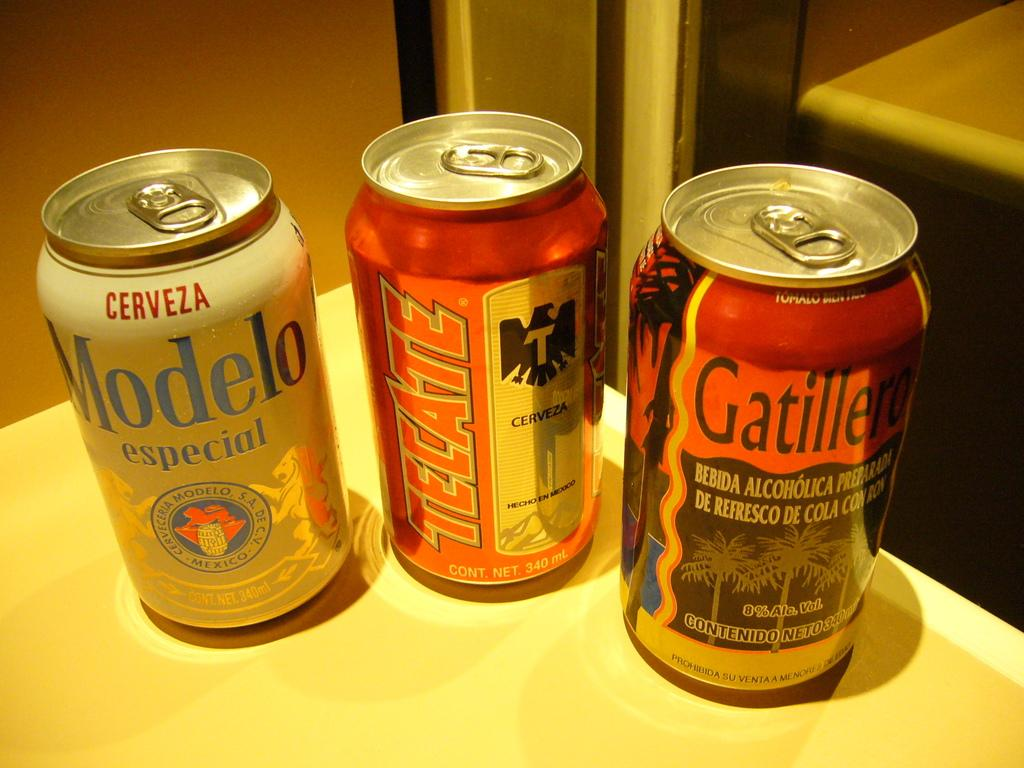<image>
Give a short and clear explanation of the subsequent image. Modelo, Tecate, and Gatillero beer cans that have not been open yet. 